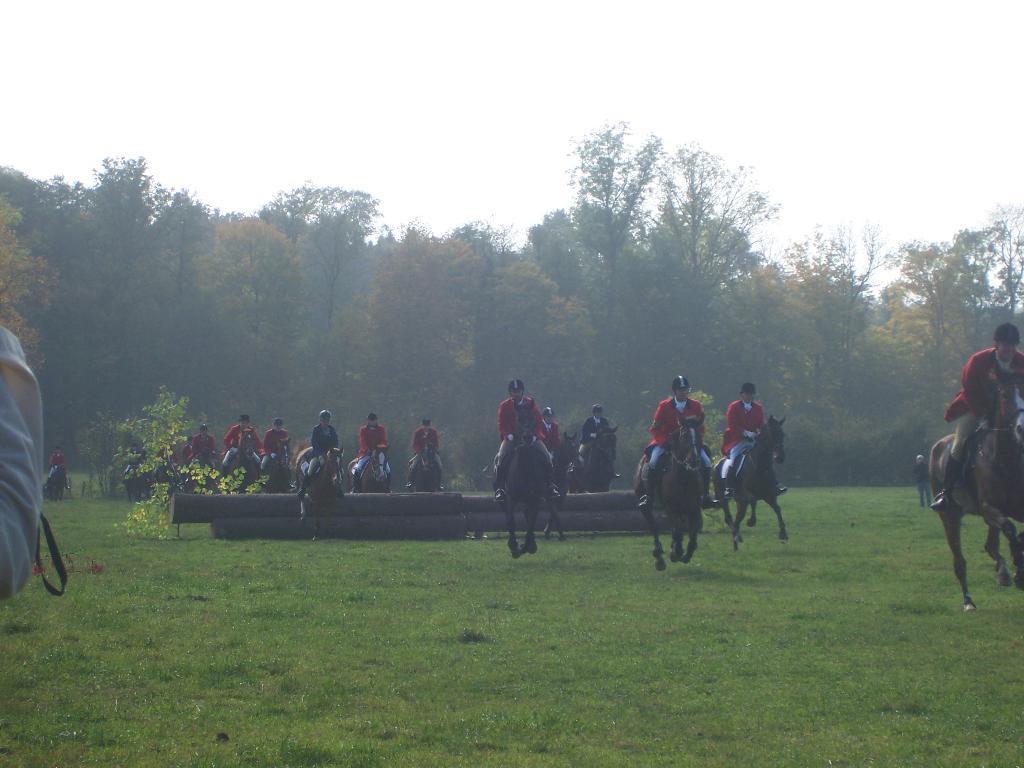Describe this image in one or two sentences. In this image I can see few horses and few people sitting on it. They are wearing red color coat and black cap. Back Side I can see a trees and black pipes on the garden. The sky is in white color. 